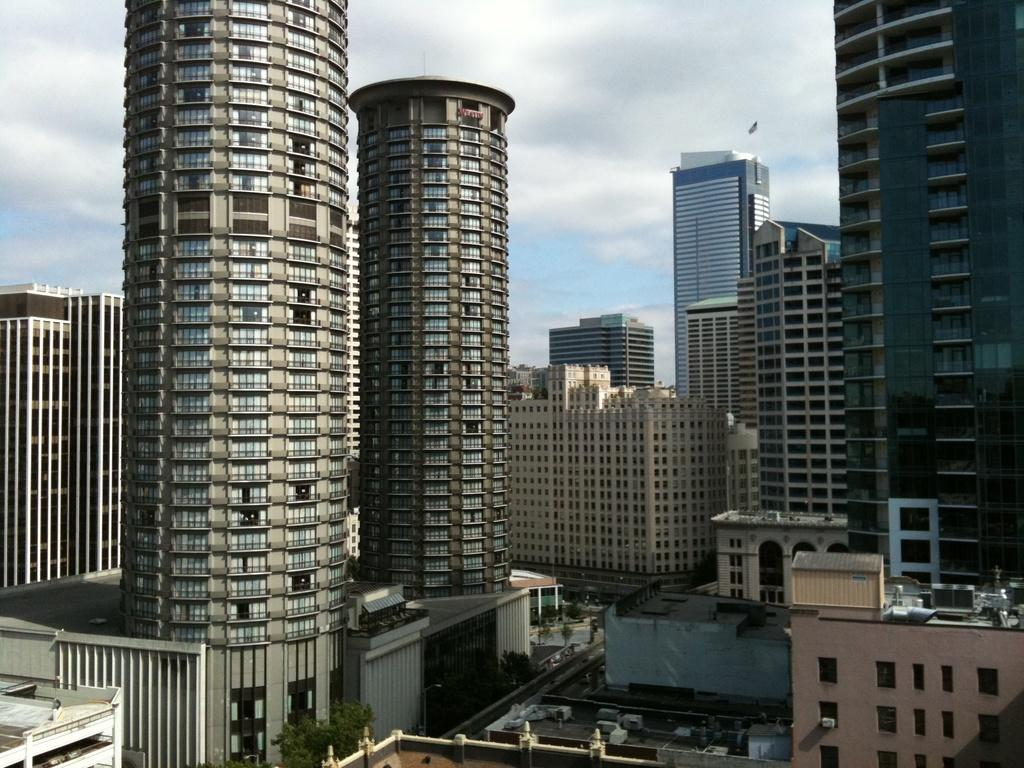What structures are present in the image? There are buildings in the image. What can be seen in the background of the image? The sky is visible in the background of the image. How would you describe the sky in the image? The sky appears to be cloudy. What type of iron is being used by the authority figure in the image? There is no iron or authority figure present in the image. What key is being used to unlock the door in the image? There is no door or key present in the image. 